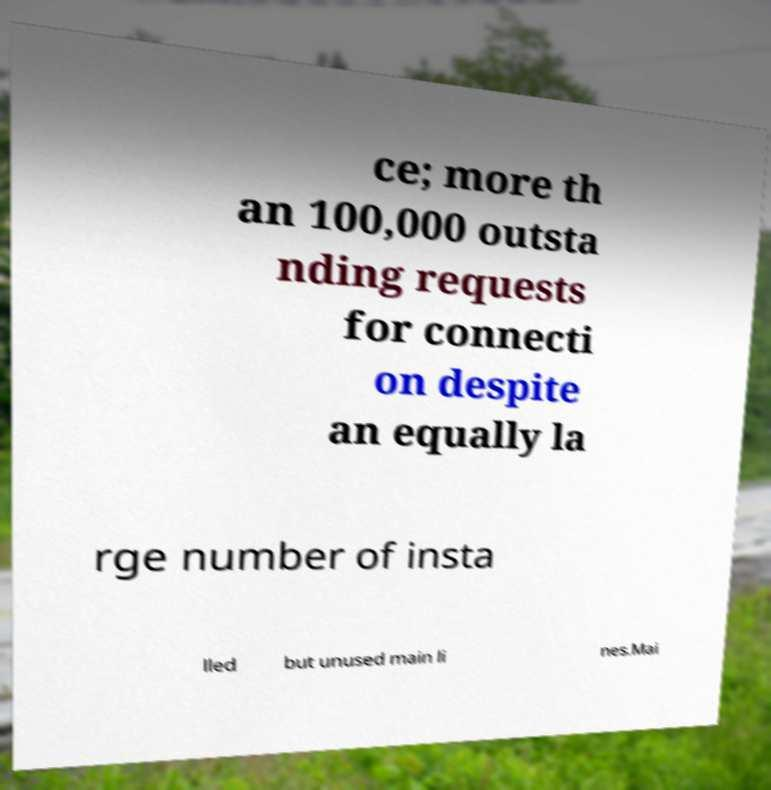Can you accurately transcribe the text from the provided image for me? ce; more th an 100,000 outsta nding requests for connecti on despite an equally la rge number of insta lled but unused main li nes.Mai 